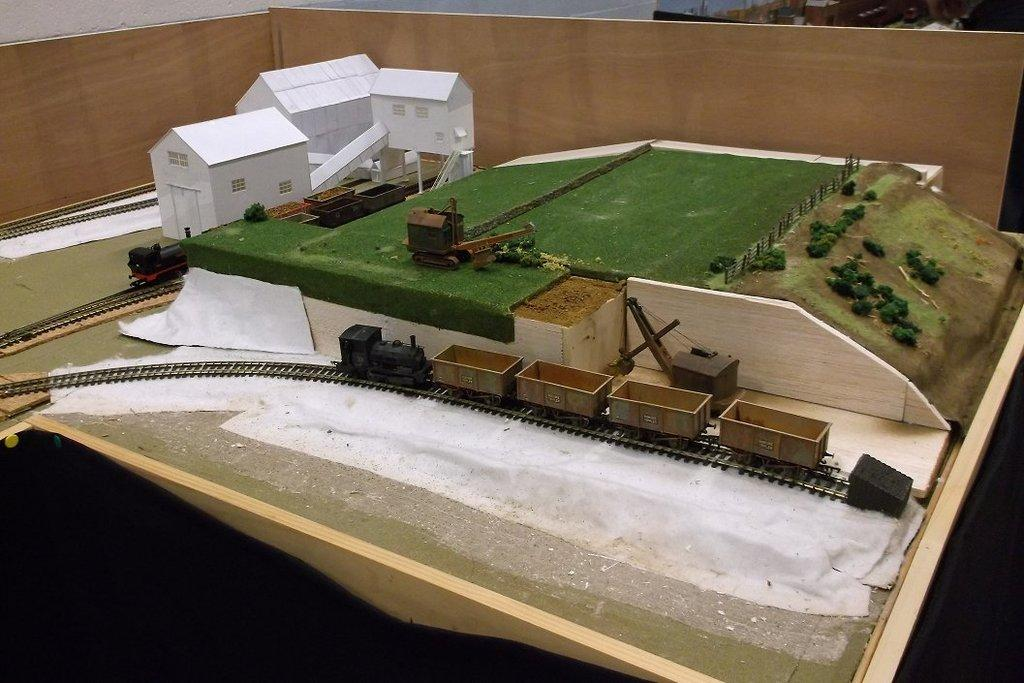What is the main subject of the image? The main subject of the image is a catalog of houses. What type of natural environment is visible in the image? There are trees and fields visible in the image. What type of transportation infrastructure is present in the image? Railway tracks and trains are present in the image. What other objects can be seen in the image? There are other objects in the image, but their specific details are not mentioned in the provided facts. What is located at the top of the image? There is a wooden plank at the top of the image. What type of pan is being used to cook food in the image? There is no pan or cooking activity visible in the image. Can you see a donkey grazing in the fields in the image? There is no donkey present in the image. 